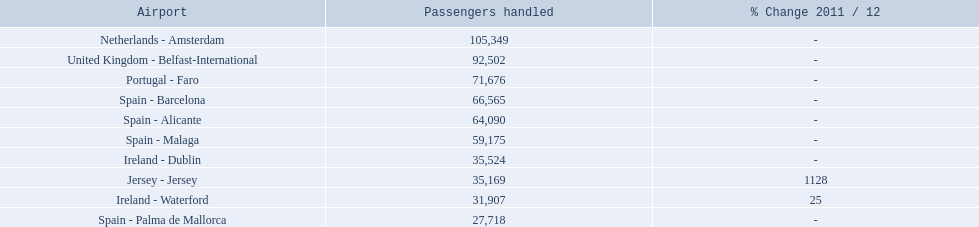Name all the london southend airports that did not list a change in 2001/12. Netherlands - Amsterdam, United Kingdom - Belfast-International, Portugal - Faro, Spain - Barcelona, Spain - Alicante, Spain - Malaga, Ireland - Dublin, Spain - Palma de Mallorca. What unchanged percentage airports from 2011/12 handled less then 50,000 passengers? Ireland - Dublin, Spain - Palma de Mallorca. What unchanged percentage airport from 2011/12 handled less then 50,000 passengers is the closest to the equator? Spain - Palma de Mallorca. 